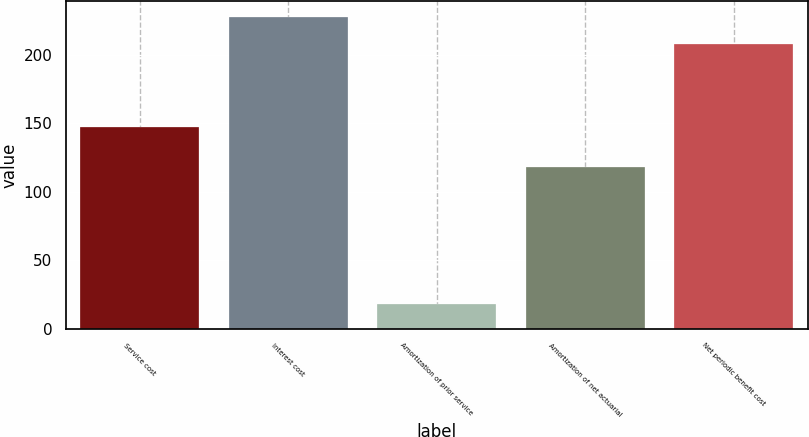Convert chart to OTSL. <chart><loc_0><loc_0><loc_500><loc_500><bar_chart><fcel>Service cost<fcel>Interest cost<fcel>Amortization of prior service<fcel>Amortization of net actuarial<fcel>Net periodic benefit cost<nl><fcel>147<fcel>227.7<fcel>18<fcel>118<fcel>208<nl></chart> 